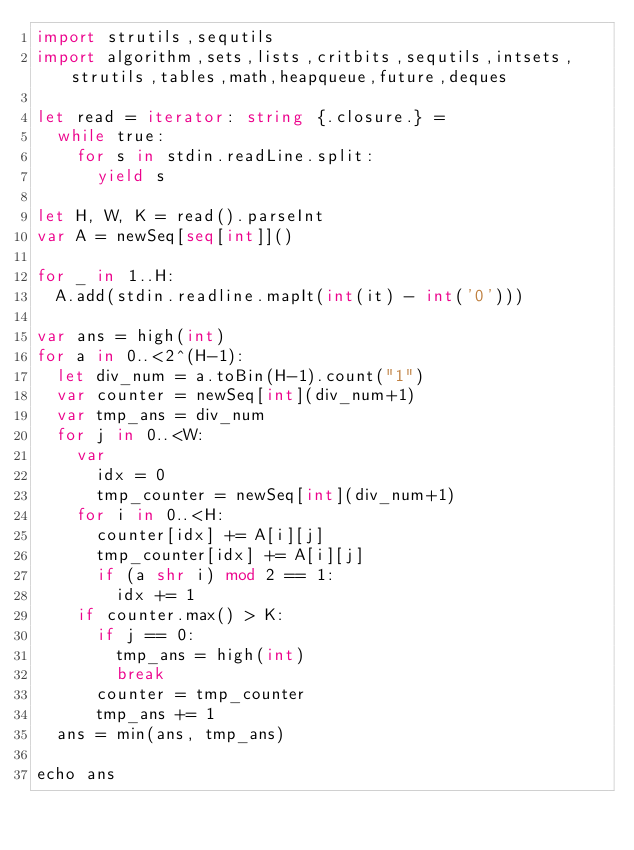<code> <loc_0><loc_0><loc_500><loc_500><_Nim_>import strutils,sequtils
import algorithm,sets,lists,critbits,sequtils,intsets,strutils,tables,math,heapqueue,future,deques

let read = iterator: string {.closure.} =
  while true:
    for s in stdin.readLine.split:
      yield s

let H, W, K = read().parseInt
var A = newSeq[seq[int]]()

for _ in 1..H:
  A.add(stdin.readline.mapIt(int(it) - int('0')))

var ans = high(int)
for a in 0..<2^(H-1):
  let div_num = a.toBin(H-1).count("1")
  var counter = newSeq[int](div_num+1)
  var tmp_ans = div_num
  for j in 0..<W:
    var
      idx = 0
      tmp_counter = newSeq[int](div_num+1)
    for i in 0..<H:
      counter[idx] += A[i][j]
      tmp_counter[idx] += A[i][j]
      if (a shr i) mod 2 == 1:
        idx += 1
    if counter.max() > K:
      if j == 0:
        tmp_ans = high(int)
        break
      counter = tmp_counter
      tmp_ans += 1
  ans = min(ans, tmp_ans)

echo ans
</code> 